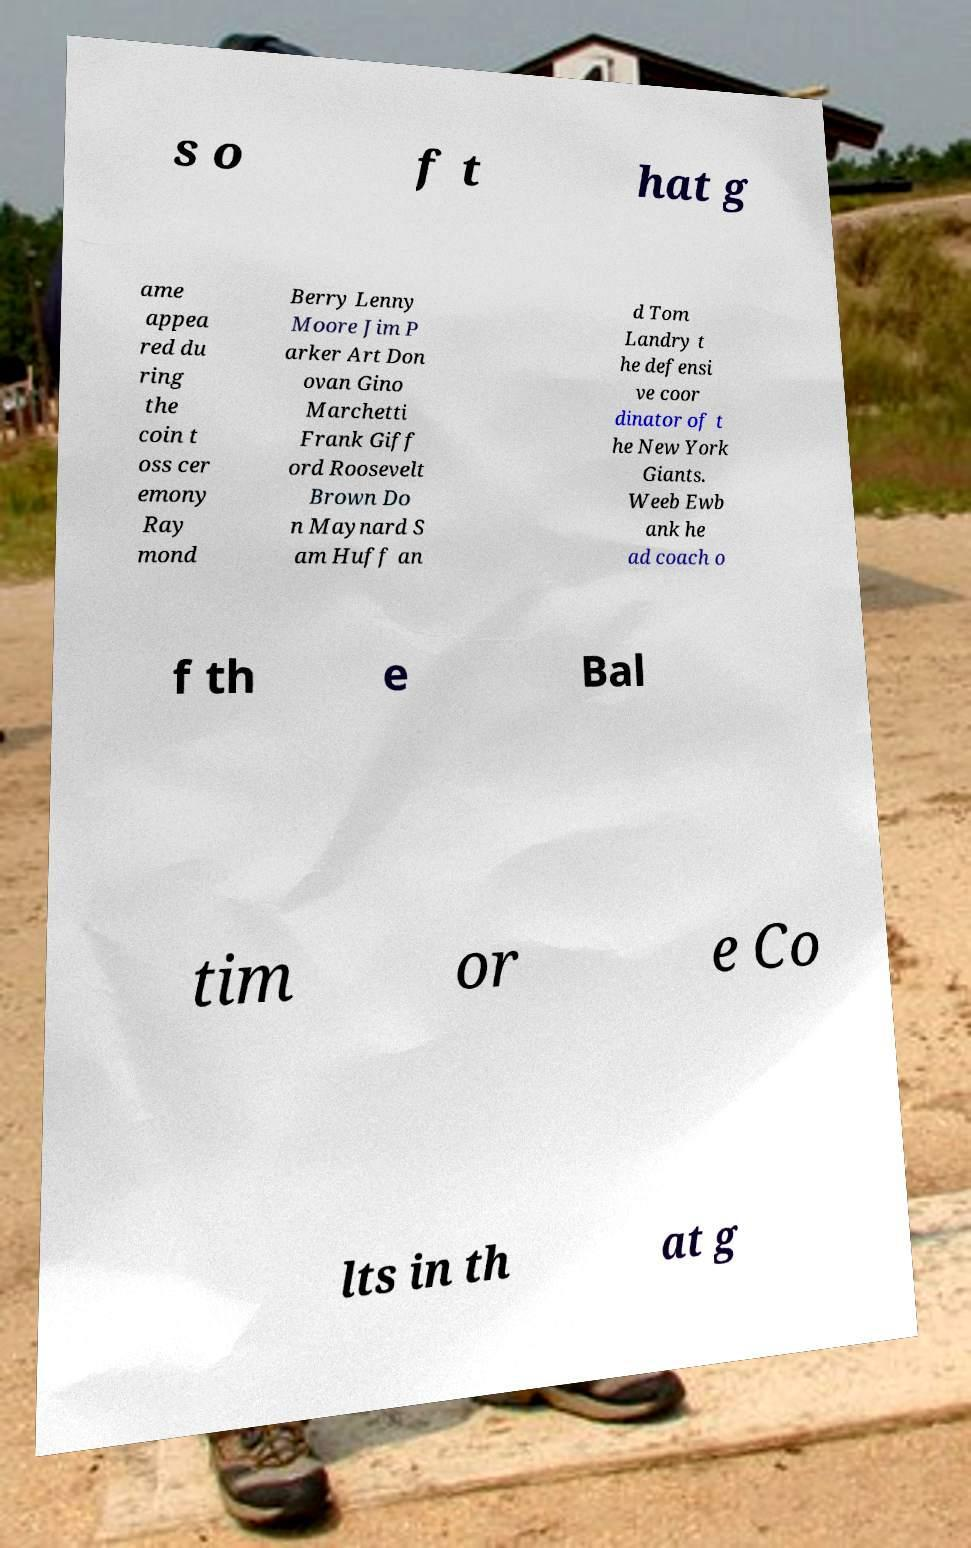What messages or text are displayed in this image? I need them in a readable, typed format. s o f t hat g ame appea red du ring the coin t oss cer emony Ray mond Berry Lenny Moore Jim P arker Art Don ovan Gino Marchetti Frank Giff ord Roosevelt Brown Do n Maynard S am Huff an d Tom Landry t he defensi ve coor dinator of t he New York Giants. Weeb Ewb ank he ad coach o f th e Bal tim or e Co lts in th at g 